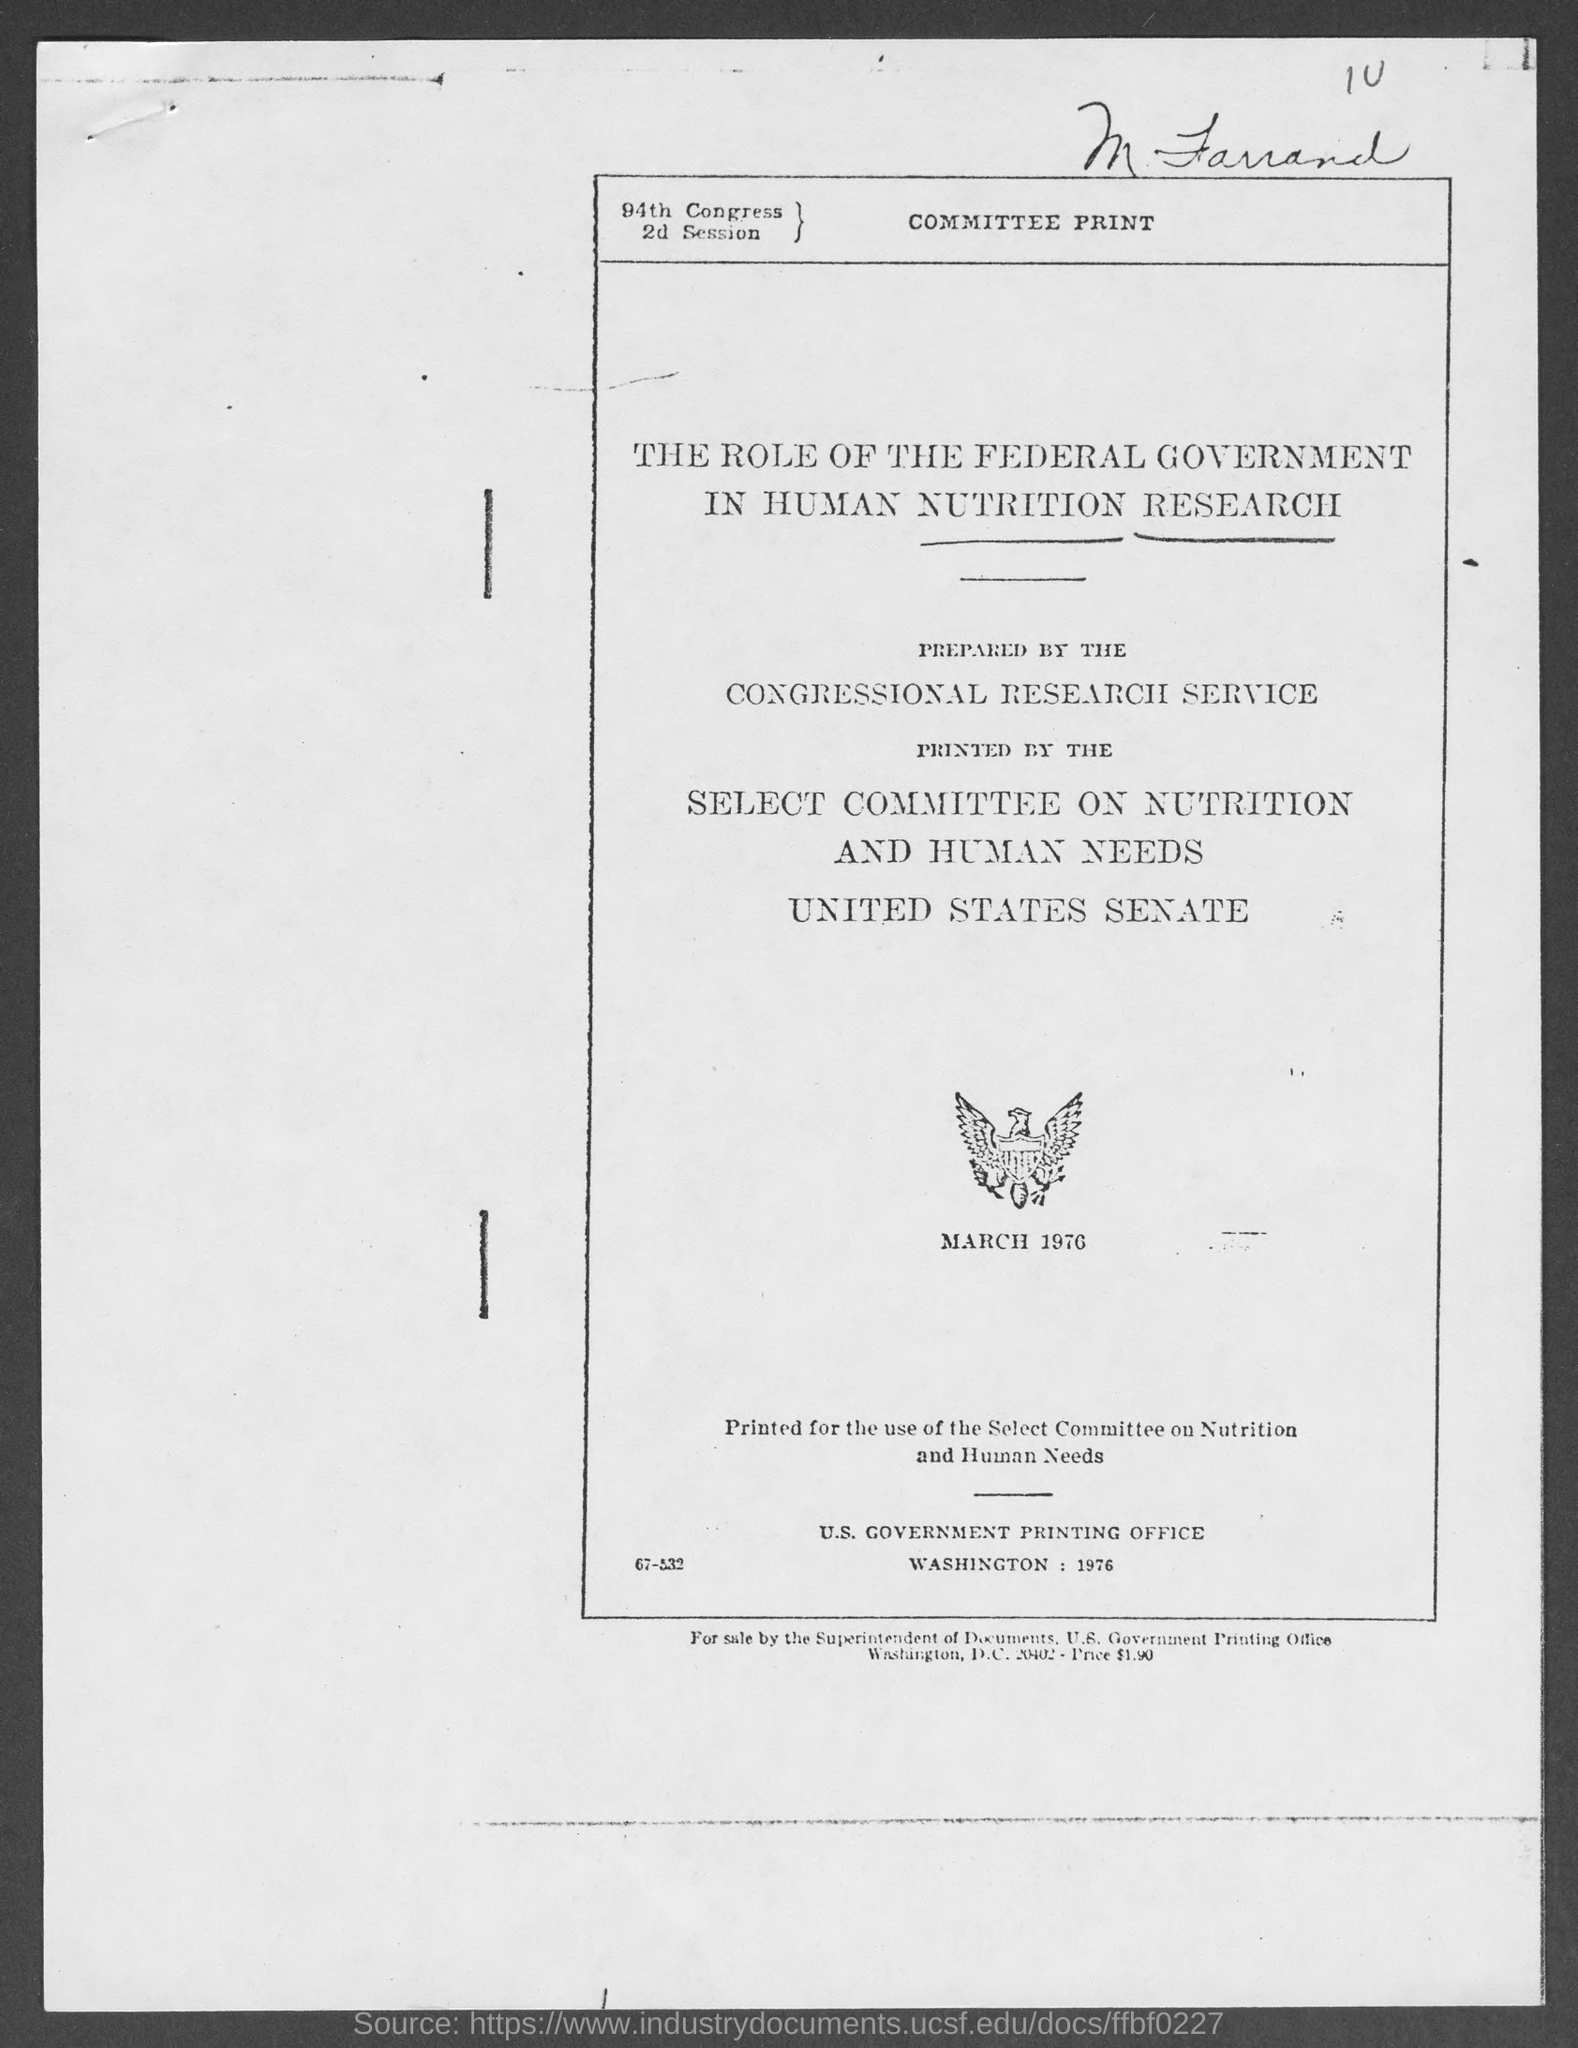List a handful of essential elements in this visual. The price at the bottom of the page is $1.90. 